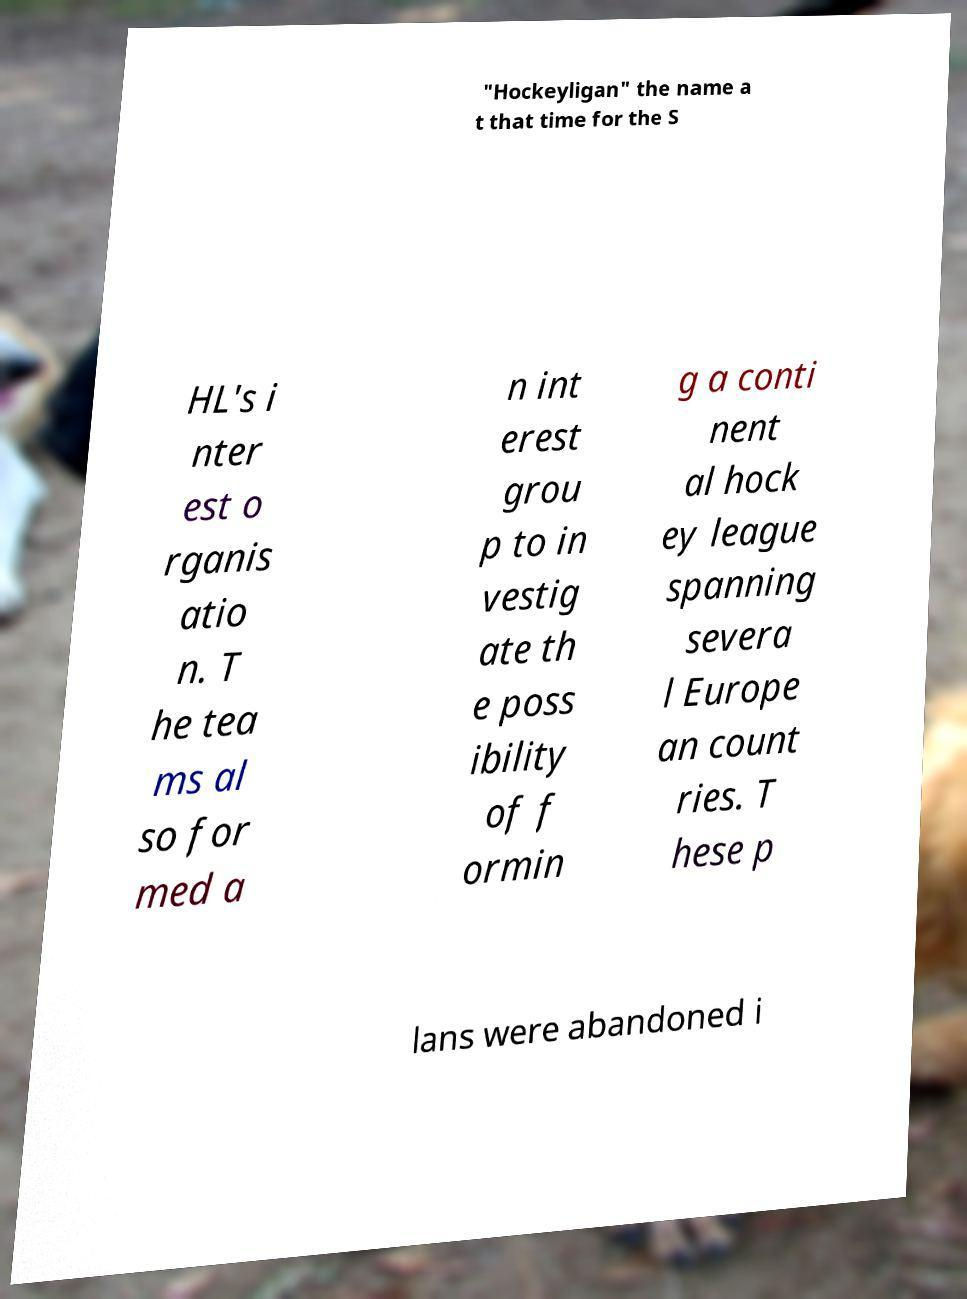For documentation purposes, I need the text within this image transcribed. Could you provide that? "Hockeyligan" the name a t that time for the S HL's i nter est o rganis atio n. T he tea ms al so for med a n int erest grou p to in vestig ate th e poss ibility of f ormin g a conti nent al hock ey league spanning severa l Europe an count ries. T hese p lans were abandoned i 